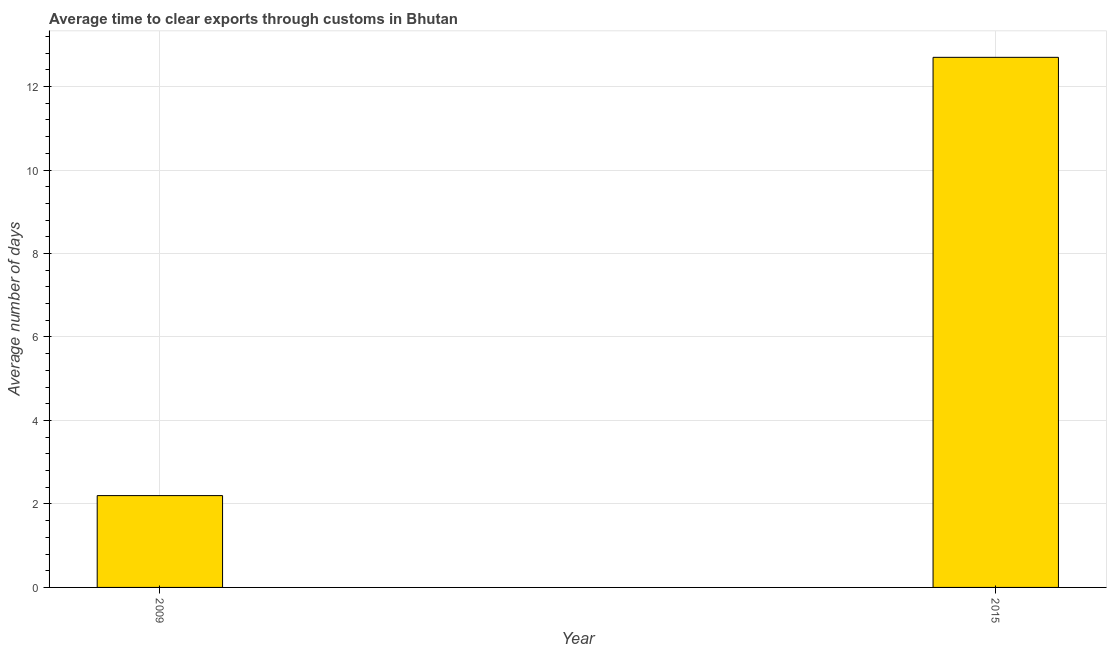Does the graph contain any zero values?
Make the answer very short. No. Does the graph contain grids?
Your response must be concise. Yes. What is the title of the graph?
Provide a short and direct response. Average time to clear exports through customs in Bhutan. What is the label or title of the Y-axis?
Keep it short and to the point. Average number of days. In which year was the time to clear exports through customs maximum?
Offer a very short reply. 2015. In which year was the time to clear exports through customs minimum?
Provide a succinct answer. 2009. What is the sum of the time to clear exports through customs?
Provide a succinct answer. 14.9. What is the difference between the time to clear exports through customs in 2009 and 2015?
Offer a terse response. -10.5. What is the average time to clear exports through customs per year?
Offer a very short reply. 7.45. What is the median time to clear exports through customs?
Offer a terse response. 7.45. What is the ratio of the time to clear exports through customs in 2009 to that in 2015?
Ensure brevity in your answer.  0.17. Is the time to clear exports through customs in 2009 less than that in 2015?
Make the answer very short. Yes. How many bars are there?
Your answer should be very brief. 2. Are all the bars in the graph horizontal?
Your answer should be very brief. No. How many years are there in the graph?
Your response must be concise. 2. What is the difference between two consecutive major ticks on the Y-axis?
Make the answer very short. 2. What is the difference between the Average number of days in 2009 and 2015?
Make the answer very short. -10.5. What is the ratio of the Average number of days in 2009 to that in 2015?
Offer a very short reply. 0.17. 